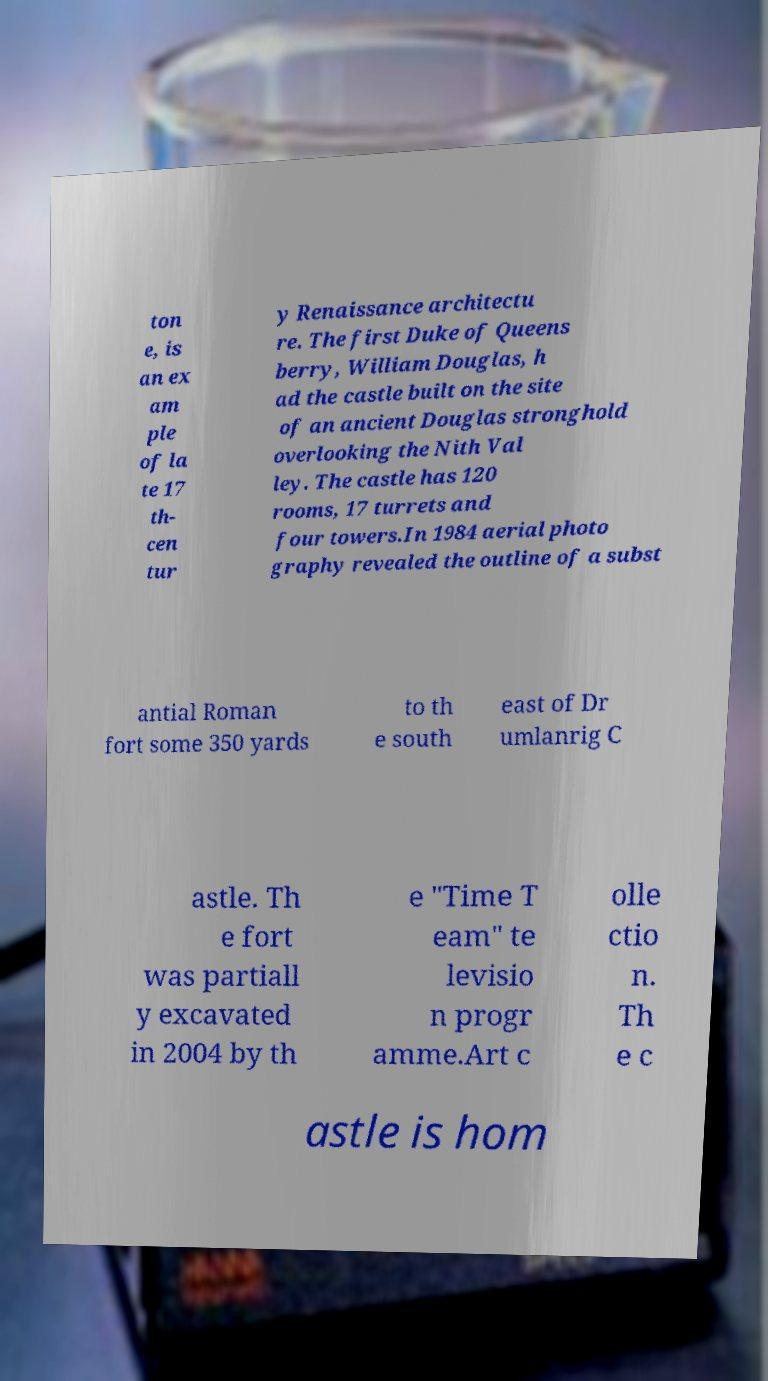There's text embedded in this image that I need extracted. Can you transcribe it verbatim? ton e, is an ex am ple of la te 17 th- cen tur y Renaissance architectu re. The first Duke of Queens berry, William Douglas, h ad the castle built on the site of an ancient Douglas stronghold overlooking the Nith Val ley. The castle has 120 rooms, 17 turrets and four towers.In 1984 aerial photo graphy revealed the outline of a subst antial Roman fort some 350 yards to th e south east of Dr umlanrig C astle. Th e fort was partiall y excavated in 2004 by th e "Time T eam" te levisio n progr amme.Art c olle ctio n. Th e c astle is hom 